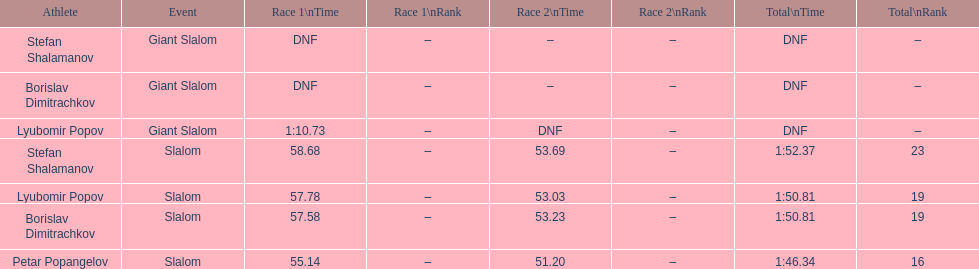What is the number of athletes to finish race one in the giant slalom? 1. 